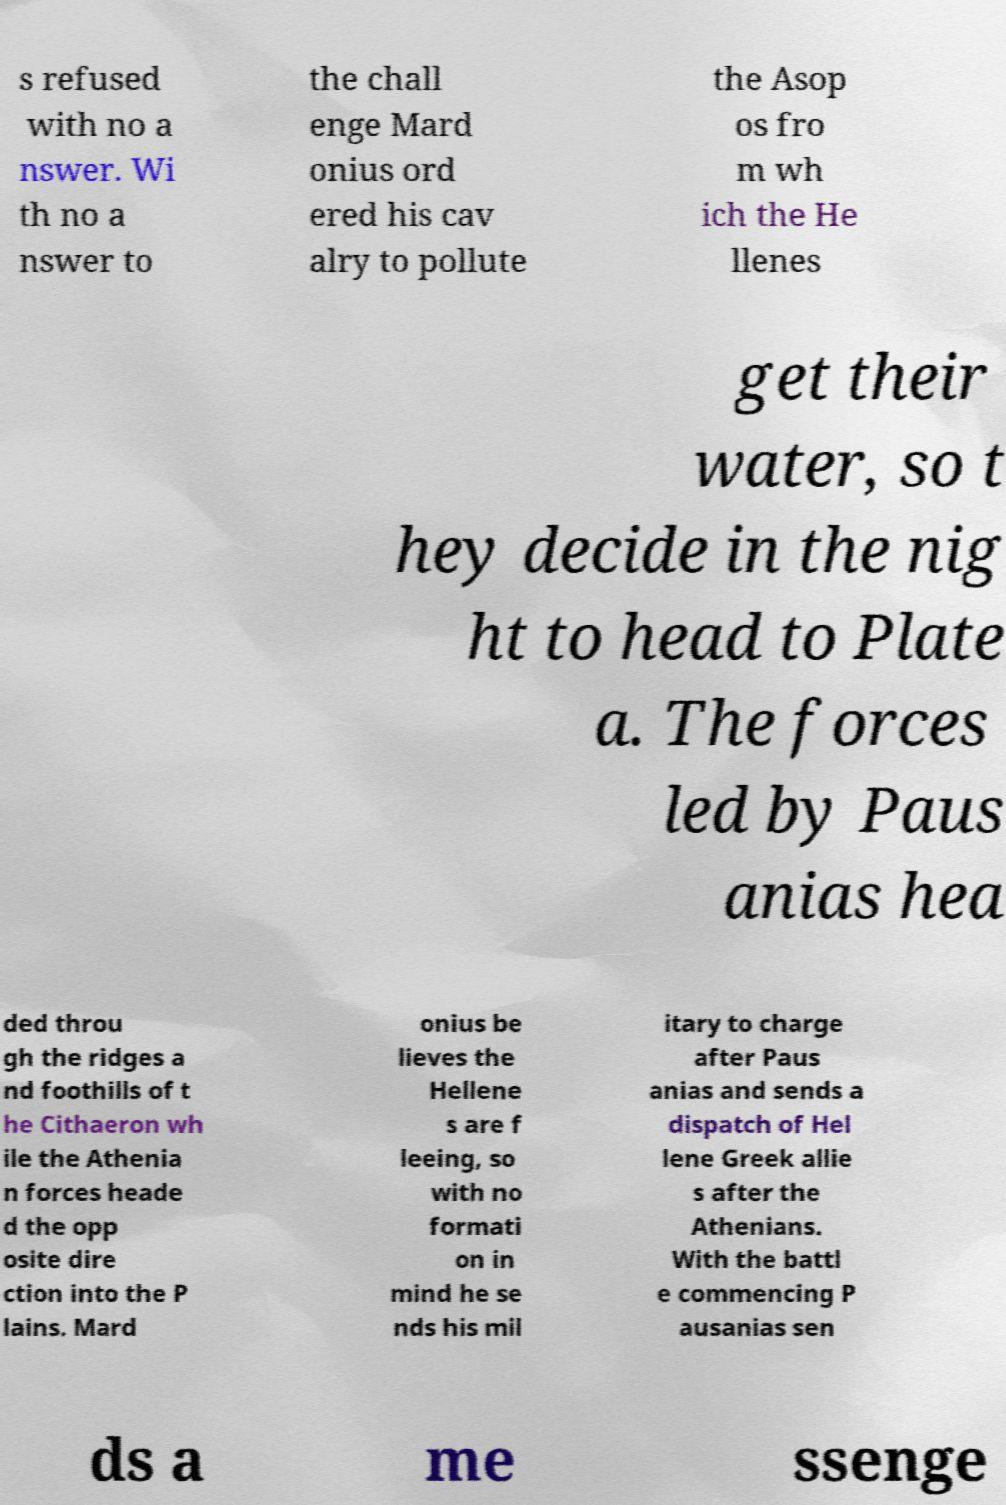I need the written content from this picture converted into text. Can you do that? s refused with no a nswer. Wi th no a nswer to the chall enge Mard onius ord ered his cav alry to pollute the Asop os fro m wh ich the He llenes get their water, so t hey decide in the nig ht to head to Plate a. The forces led by Paus anias hea ded throu gh the ridges a nd foothills of t he Cithaeron wh ile the Athenia n forces heade d the opp osite dire ction into the P lains. Mard onius be lieves the Hellene s are f leeing, so with no formati on in mind he se nds his mil itary to charge after Paus anias and sends a dispatch of Hel lene Greek allie s after the Athenians. With the battl e commencing P ausanias sen ds a me ssenge 